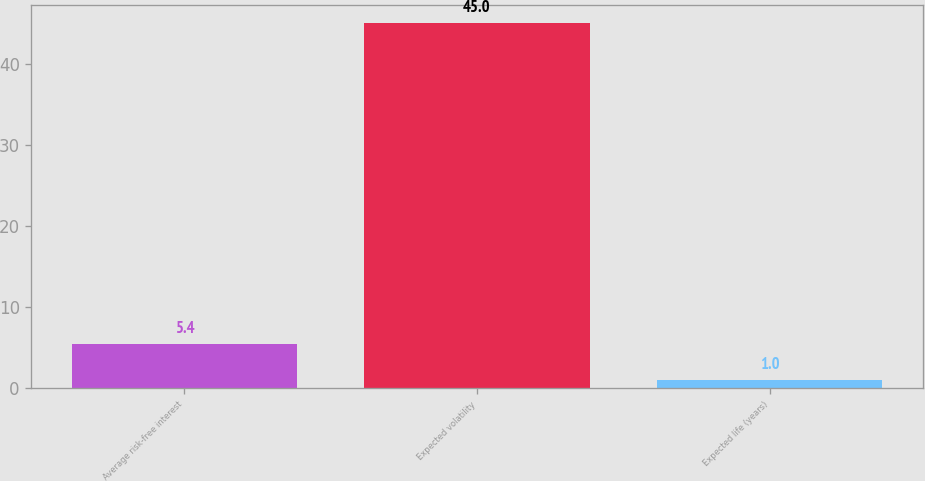Convert chart to OTSL. <chart><loc_0><loc_0><loc_500><loc_500><bar_chart><fcel>Average risk-free interest<fcel>Expected volatility<fcel>Expected life (years)<nl><fcel>5.4<fcel>45<fcel>1<nl></chart> 